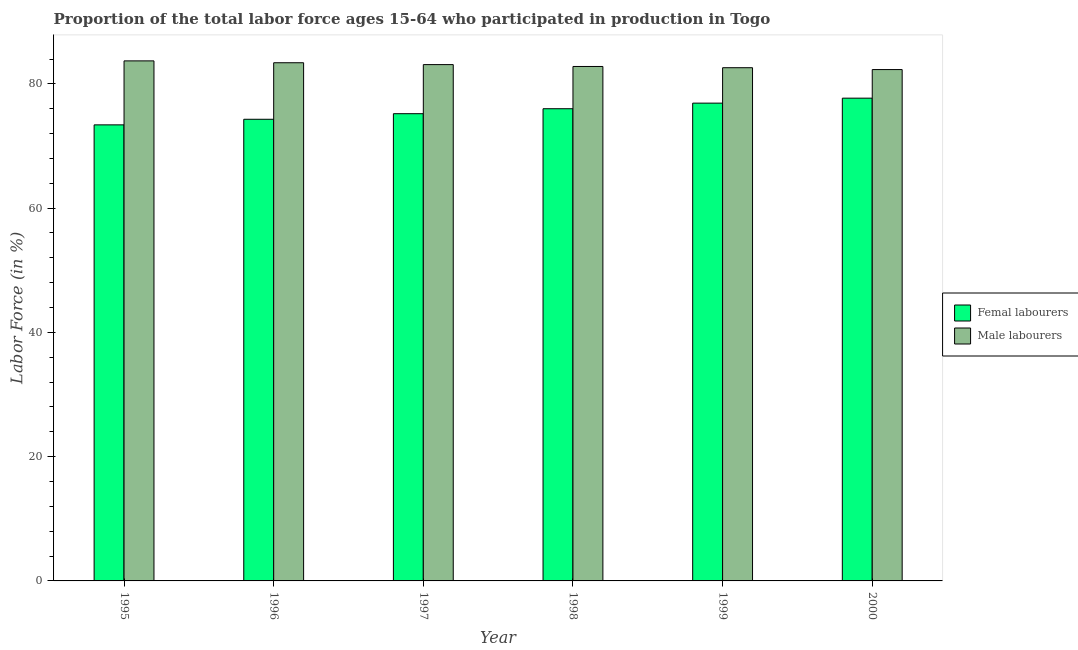How many groups of bars are there?
Keep it short and to the point. 6. Are the number of bars on each tick of the X-axis equal?
Make the answer very short. Yes. How many bars are there on the 6th tick from the left?
Provide a short and direct response. 2. How many bars are there on the 6th tick from the right?
Provide a short and direct response. 2. In how many cases, is the number of bars for a given year not equal to the number of legend labels?
Provide a short and direct response. 0. What is the percentage of male labour force in 1999?
Provide a succinct answer. 82.6. Across all years, what is the maximum percentage of female labor force?
Your response must be concise. 77.7. Across all years, what is the minimum percentage of male labour force?
Provide a short and direct response. 82.3. In which year was the percentage of male labour force minimum?
Offer a very short reply. 2000. What is the total percentage of male labour force in the graph?
Offer a very short reply. 497.9. What is the difference between the percentage of female labor force in 1995 and that in 2000?
Make the answer very short. -4.3. What is the difference between the percentage of male labour force in 1996 and the percentage of female labor force in 1999?
Offer a terse response. 0.8. What is the average percentage of female labor force per year?
Ensure brevity in your answer.  75.58. In the year 1995, what is the difference between the percentage of male labour force and percentage of female labor force?
Make the answer very short. 0. What is the ratio of the percentage of female labor force in 1995 to that in 2000?
Your answer should be compact. 0.94. Is the difference between the percentage of female labor force in 1995 and 1996 greater than the difference between the percentage of male labour force in 1995 and 1996?
Give a very brief answer. No. What is the difference between the highest and the second highest percentage of female labor force?
Your response must be concise. 0.8. What is the difference between the highest and the lowest percentage of female labor force?
Ensure brevity in your answer.  4.3. In how many years, is the percentage of female labor force greater than the average percentage of female labor force taken over all years?
Provide a short and direct response. 3. Is the sum of the percentage of male labour force in 1995 and 1998 greater than the maximum percentage of female labor force across all years?
Offer a terse response. Yes. What does the 1st bar from the left in 1995 represents?
Your answer should be very brief. Femal labourers. What does the 2nd bar from the right in 1996 represents?
Your response must be concise. Femal labourers. How many years are there in the graph?
Make the answer very short. 6. Are the values on the major ticks of Y-axis written in scientific E-notation?
Offer a very short reply. No. Does the graph contain grids?
Provide a succinct answer. No. Where does the legend appear in the graph?
Your answer should be compact. Center right. How many legend labels are there?
Ensure brevity in your answer.  2. How are the legend labels stacked?
Offer a very short reply. Vertical. What is the title of the graph?
Your response must be concise. Proportion of the total labor force ages 15-64 who participated in production in Togo. What is the label or title of the Y-axis?
Ensure brevity in your answer.  Labor Force (in %). What is the Labor Force (in %) in Femal labourers in 1995?
Keep it short and to the point. 73.4. What is the Labor Force (in %) of Male labourers in 1995?
Provide a succinct answer. 83.7. What is the Labor Force (in %) of Femal labourers in 1996?
Your response must be concise. 74.3. What is the Labor Force (in %) in Male labourers in 1996?
Offer a very short reply. 83.4. What is the Labor Force (in %) of Femal labourers in 1997?
Make the answer very short. 75.2. What is the Labor Force (in %) of Male labourers in 1997?
Ensure brevity in your answer.  83.1. What is the Labor Force (in %) of Male labourers in 1998?
Give a very brief answer. 82.8. What is the Labor Force (in %) of Femal labourers in 1999?
Make the answer very short. 76.9. What is the Labor Force (in %) in Male labourers in 1999?
Ensure brevity in your answer.  82.6. What is the Labor Force (in %) of Femal labourers in 2000?
Provide a succinct answer. 77.7. What is the Labor Force (in %) of Male labourers in 2000?
Your answer should be very brief. 82.3. Across all years, what is the maximum Labor Force (in %) in Femal labourers?
Offer a very short reply. 77.7. Across all years, what is the maximum Labor Force (in %) in Male labourers?
Provide a short and direct response. 83.7. Across all years, what is the minimum Labor Force (in %) in Femal labourers?
Keep it short and to the point. 73.4. Across all years, what is the minimum Labor Force (in %) in Male labourers?
Offer a terse response. 82.3. What is the total Labor Force (in %) of Femal labourers in the graph?
Your answer should be very brief. 453.5. What is the total Labor Force (in %) of Male labourers in the graph?
Make the answer very short. 497.9. What is the difference between the Labor Force (in %) of Male labourers in 1995 and that in 1996?
Keep it short and to the point. 0.3. What is the difference between the Labor Force (in %) of Femal labourers in 1995 and that in 1997?
Provide a short and direct response. -1.8. What is the difference between the Labor Force (in %) in Male labourers in 1995 and that in 1997?
Make the answer very short. 0.6. What is the difference between the Labor Force (in %) of Femal labourers in 1995 and that in 1998?
Provide a succinct answer. -2.6. What is the difference between the Labor Force (in %) of Male labourers in 1995 and that in 1998?
Ensure brevity in your answer.  0.9. What is the difference between the Labor Force (in %) in Male labourers in 1995 and that in 2000?
Your answer should be very brief. 1.4. What is the difference between the Labor Force (in %) in Male labourers in 1996 and that in 1997?
Give a very brief answer. 0.3. What is the difference between the Labor Force (in %) of Femal labourers in 1996 and that in 1998?
Keep it short and to the point. -1.7. What is the difference between the Labor Force (in %) in Male labourers in 1996 and that in 1998?
Your answer should be compact. 0.6. What is the difference between the Labor Force (in %) in Femal labourers in 1996 and that in 2000?
Provide a short and direct response. -3.4. What is the difference between the Labor Force (in %) in Male labourers in 1997 and that in 1998?
Provide a succinct answer. 0.3. What is the difference between the Labor Force (in %) in Femal labourers in 1997 and that in 1999?
Keep it short and to the point. -1.7. What is the difference between the Labor Force (in %) of Male labourers in 1997 and that in 1999?
Offer a very short reply. 0.5. What is the difference between the Labor Force (in %) of Male labourers in 1998 and that in 1999?
Provide a succinct answer. 0.2. What is the difference between the Labor Force (in %) in Femal labourers in 1998 and that in 2000?
Provide a short and direct response. -1.7. What is the difference between the Labor Force (in %) of Femal labourers in 1999 and that in 2000?
Give a very brief answer. -0.8. What is the difference between the Labor Force (in %) of Male labourers in 1999 and that in 2000?
Provide a short and direct response. 0.3. What is the difference between the Labor Force (in %) of Femal labourers in 1995 and the Labor Force (in %) of Male labourers in 1996?
Provide a succinct answer. -10. What is the difference between the Labor Force (in %) of Femal labourers in 1995 and the Labor Force (in %) of Male labourers in 1999?
Offer a very short reply. -9.2. What is the difference between the Labor Force (in %) of Femal labourers in 1996 and the Labor Force (in %) of Male labourers in 1997?
Offer a terse response. -8.8. What is the difference between the Labor Force (in %) of Femal labourers in 1996 and the Labor Force (in %) of Male labourers in 2000?
Provide a short and direct response. -8. What is the difference between the Labor Force (in %) of Femal labourers in 1997 and the Labor Force (in %) of Male labourers in 1998?
Ensure brevity in your answer.  -7.6. What is the difference between the Labor Force (in %) in Femal labourers in 1997 and the Labor Force (in %) in Male labourers in 1999?
Provide a succinct answer. -7.4. What is the difference between the Labor Force (in %) in Femal labourers in 1997 and the Labor Force (in %) in Male labourers in 2000?
Make the answer very short. -7.1. What is the difference between the Labor Force (in %) in Femal labourers in 1998 and the Labor Force (in %) in Male labourers in 2000?
Provide a succinct answer. -6.3. What is the average Labor Force (in %) in Femal labourers per year?
Your answer should be very brief. 75.58. What is the average Labor Force (in %) in Male labourers per year?
Give a very brief answer. 82.98. In the year 1995, what is the difference between the Labor Force (in %) of Femal labourers and Labor Force (in %) of Male labourers?
Provide a short and direct response. -10.3. In the year 1996, what is the difference between the Labor Force (in %) in Femal labourers and Labor Force (in %) in Male labourers?
Keep it short and to the point. -9.1. In the year 1998, what is the difference between the Labor Force (in %) in Femal labourers and Labor Force (in %) in Male labourers?
Keep it short and to the point. -6.8. What is the ratio of the Labor Force (in %) of Femal labourers in 1995 to that in 1996?
Offer a very short reply. 0.99. What is the ratio of the Labor Force (in %) of Male labourers in 1995 to that in 1996?
Give a very brief answer. 1. What is the ratio of the Labor Force (in %) of Femal labourers in 1995 to that in 1997?
Ensure brevity in your answer.  0.98. What is the ratio of the Labor Force (in %) in Femal labourers in 1995 to that in 1998?
Keep it short and to the point. 0.97. What is the ratio of the Labor Force (in %) in Male labourers in 1995 to that in 1998?
Make the answer very short. 1.01. What is the ratio of the Labor Force (in %) in Femal labourers in 1995 to that in 1999?
Your answer should be compact. 0.95. What is the ratio of the Labor Force (in %) of Male labourers in 1995 to that in 1999?
Ensure brevity in your answer.  1.01. What is the ratio of the Labor Force (in %) in Femal labourers in 1995 to that in 2000?
Offer a very short reply. 0.94. What is the ratio of the Labor Force (in %) of Male labourers in 1995 to that in 2000?
Keep it short and to the point. 1.02. What is the ratio of the Labor Force (in %) of Male labourers in 1996 to that in 1997?
Your answer should be compact. 1. What is the ratio of the Labor Force (in %) of Femal labourers in 1996 to that in 1998?
Provide a succinct answer. 0.98. What is the ratio of the Labor Force (in %) in Male labourers in 1996 to that in 1998?
Keep it short and to the point. 1.01. What is the ratio of the Labor Force (in %) in Femal labourers in 1996 to that in 1999?
Make the answer very short. 0.97. What is the ratio of the Labor Force (in %) of Male labourers in 1996 to that in 1999?
Your answer should be compact. 1.01. What is the ratio of the Labor Force (in %) in Femal labourers in 1996 to that in 2000?
Your answer should be compact. 0.96. What is the ratio of the Labor Force (in %) in Male labourers in 1996 to that in 2000?
Provide a short and direct response. 1.01. What is the ratio of the Labor Force (in %) in Femal labourers in 1997 to that in 1998?
Offer a terse response. 0.99. What is the ratio of the Labor Force (in %) in Femal labourers in 1997 to that in 1999?
Give a very brief answer. 0.98. What is the ratio of the Labor Force (in %) of Femal labourers in 1997 to that in 2000?
Ensure brevity in your answer.  0.97. What is the ratio of the Labor Force (in %) of Male labourers in 1997 to that in 2000?
Ensure brevity in your answer.  1.01. What is the ratio of the Labor Force (in %) of Femal labourers in 1998 to that in 1999?
Ensure brevity in your answer.  0.99. What is the ratio of the Labor Force (in %) of Femal labourers in 1998 to that in 2000?
Keep it short and to the point. 0.98. What is the ratio of the Labor Force (in %) in Femal labourers in 1999 to that in 2000?
Your answer should be compact. 0.99. What is the ratio of the Labor Force (in %) of Male labourers in 1999 to that in 2000?
Your answer should be compact. 1. What is the difference between the highest and the second highest Labor Force (in %) of Femal labourers?
Your answer should be compact. 0.8. What is the difference between the highest and the second highest Labor Force (in %) of Male labourers?
Offer a terse response. 0.3. What is the difference between the highest and the lowest Labor Force (in %) in Femal labourers?
Keep it short and to the point. 4.3. 